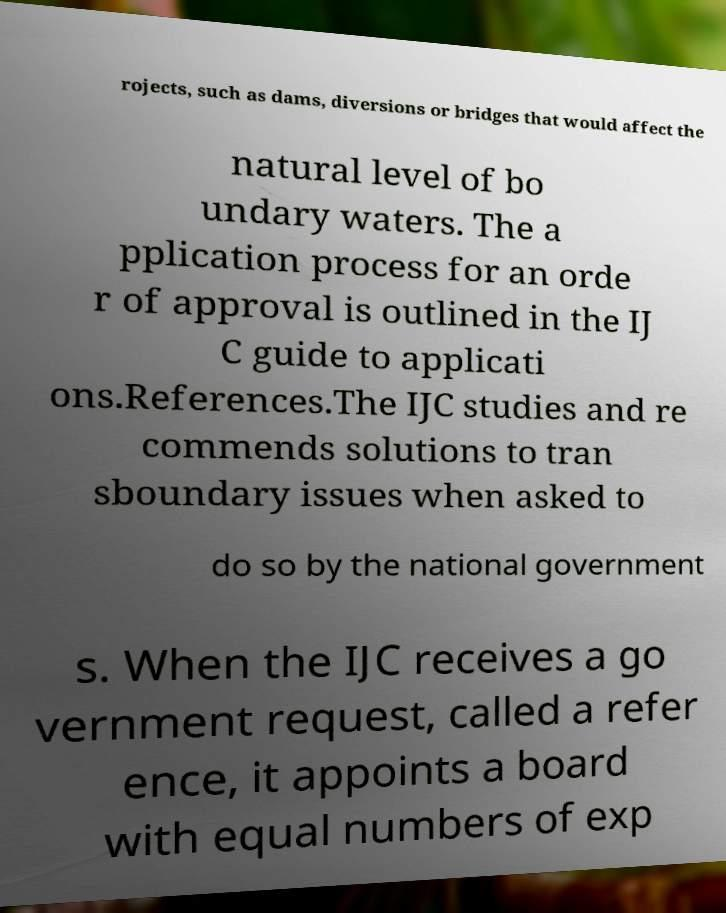There's text embedded in this image that I need extracted. Can you transcribe it verbatim? rojects, such as dams, diversions or bridges that would affect the natural level of bo undary waters. The a pplication process for an orde r of approval is outlined in the IJ C guide to applicati ons.References.The IJC studies and re commends solutions to tran sboundary issues when asked to do so by the national government s. When the IJC receives a go vernment request, called a refer ence, it appoints a board with equal numbers of exp 